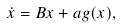<formula> <loc_0><loc_0><loc_500><loc_500>\dot { x } = B x + a g ( x ) ,</formula> 